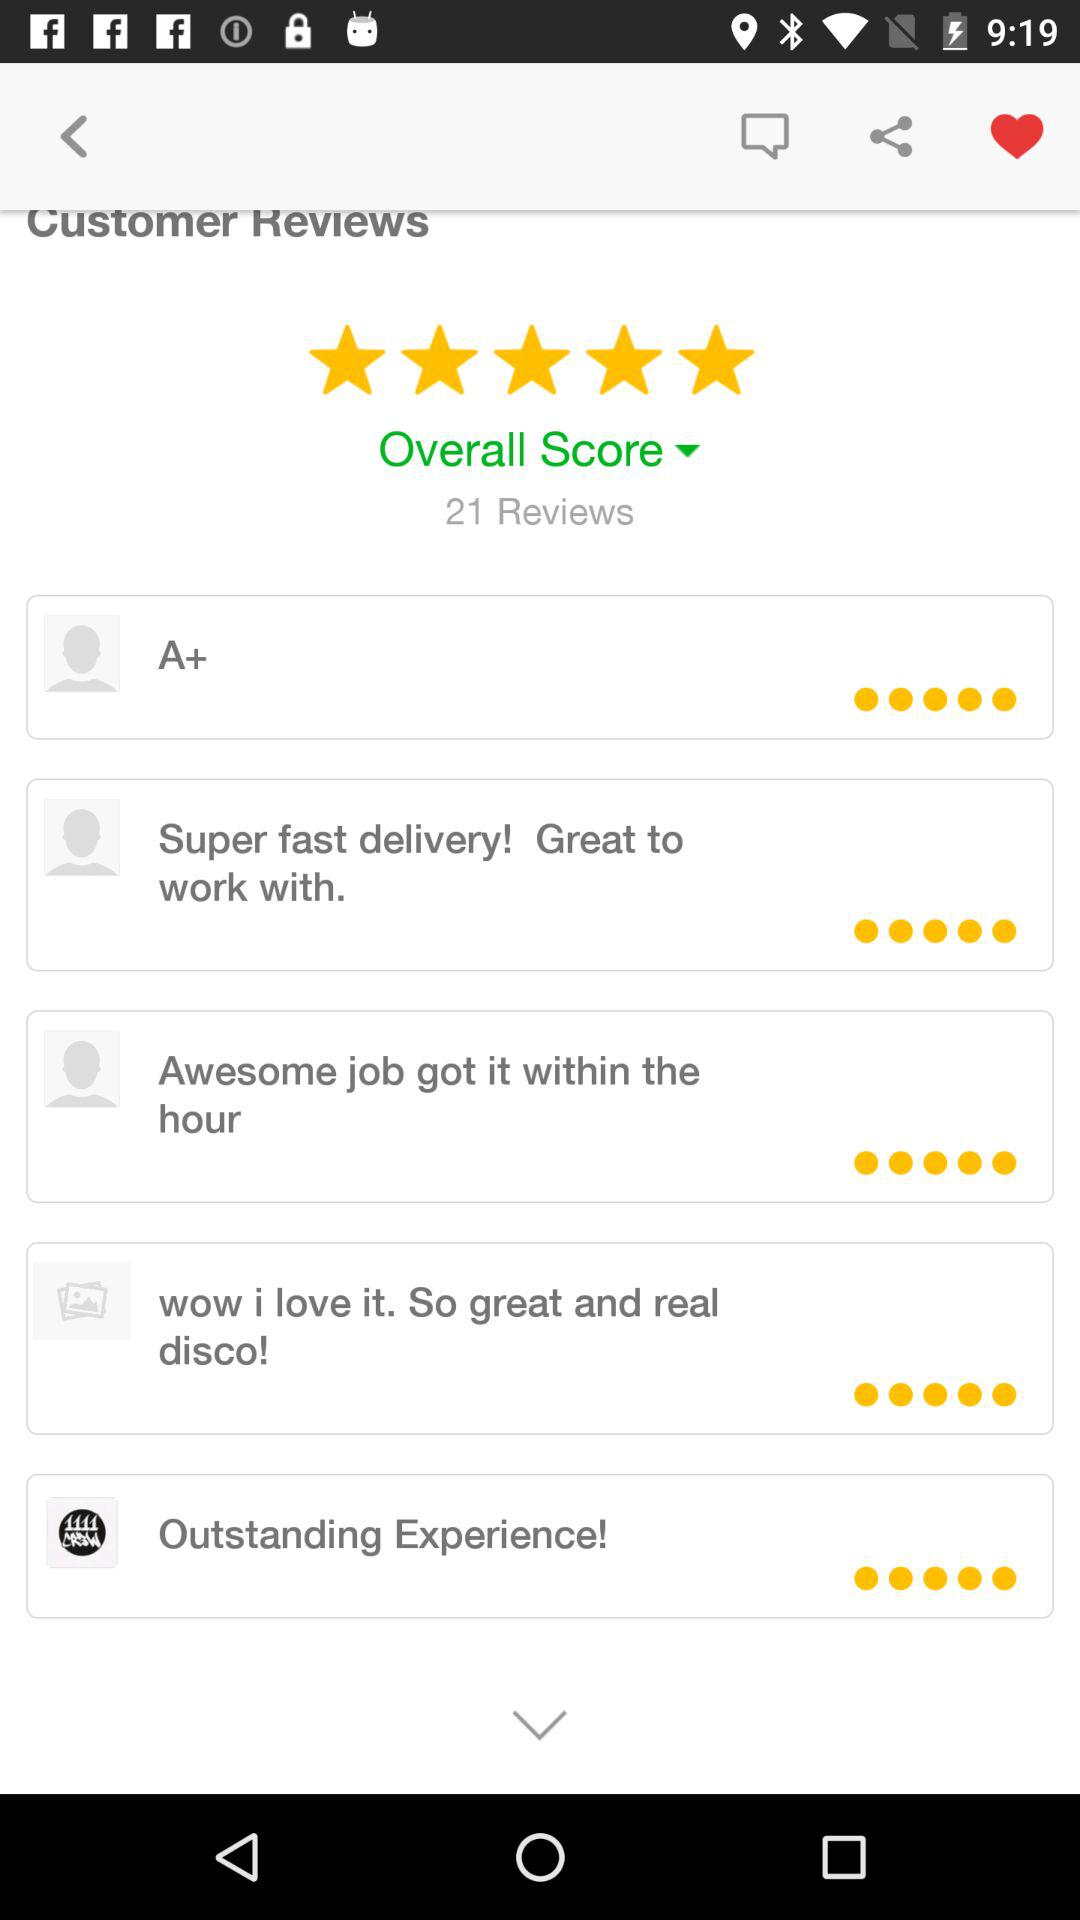What are the customer reviews on the screen? The customer reviews on the screen are "A+", "Super fast delivery! Great to work with.", "Awesome job got it within the hour", "wow i love it. So great and real disco!" and "Outstanding Experience!". 